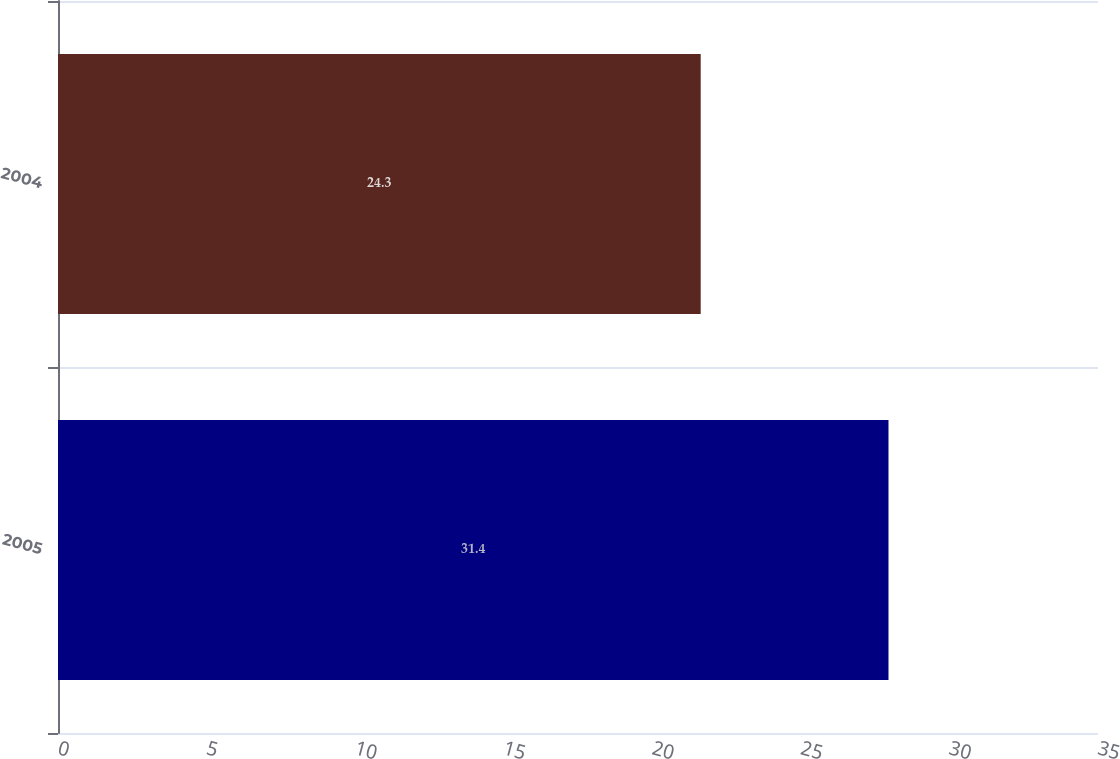Convert chart to OTSL. <chart><loc_0><loc_0><loc_500><loc_500><bar_chart><fcel>2005<fcel>2004<nl><fcel>31.4<fcel>24.3<nl></chart> 